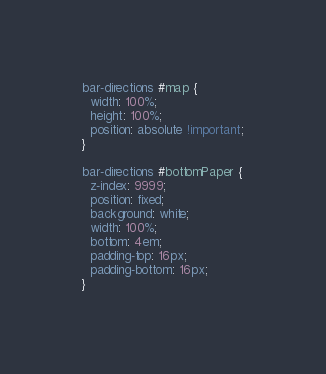<code> <loc_0><loc_0><loc_500><loc_500><_CSS_>bar-directions #map {
  width: 100%;
  height: 100%;
  position: absolute !important;
}

bar-directions #bottomPaper {
  z-index: 9999;
  position: fixed;
  background: white;
  width: 100%;
  bottom: 4em;
  padding-top: 16px;
  padding-bottom: 16px;
}
</code> 